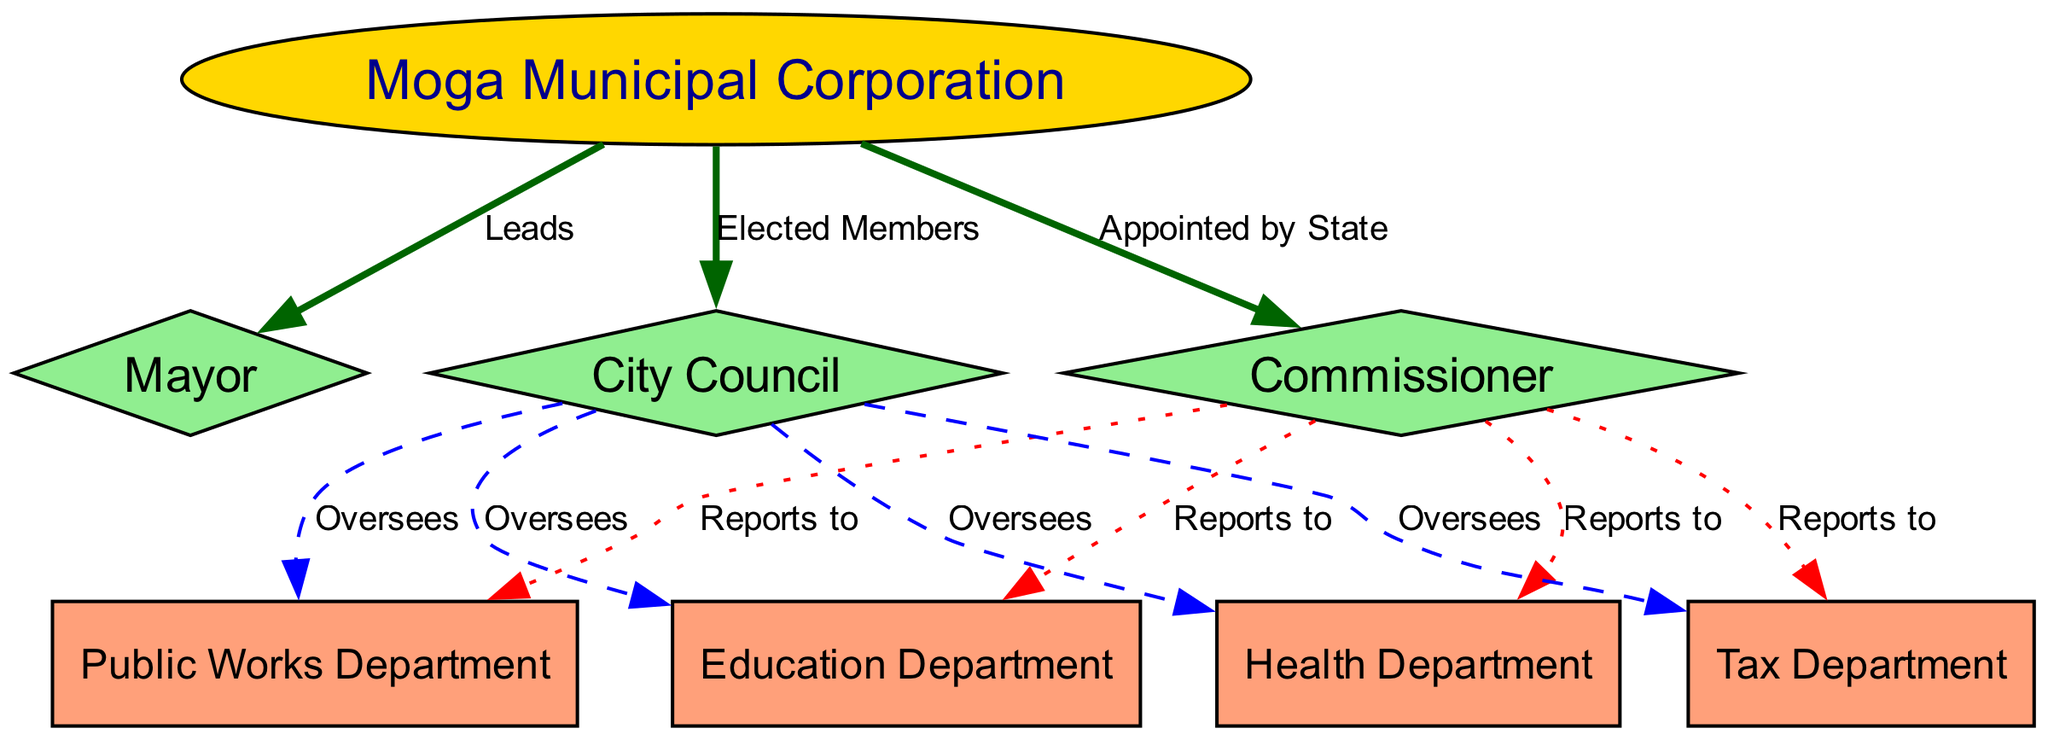What is the main entity in the diagram? The primary entity represented in the diagram is the Moga Municipal Corporation, denoted by the node labeled "Moga Municipal Corporation". It is represented as an ellipse, indicating its significance as the main organization overseeing local governance.
Answer: Moga Municipal Corporation How many departments are overseen by the City Council? The City Council oversees four departments, which include the Health Department, Education Department, Public Works Department, and Tax Department, as indicated by the four directed edges going from the Council to these departments.
Answer: 4 Who is appointed by the State? The Commissioner is the individual appointed by the State, as indicated by the edge labeled "Appointed by State" that connects the Moga Municipal Corporation to the Commissioner.
Answer: Commissioner What type of relationship does the Council have with the departments? The relationship between the Council and the departments is one of oversight, as indicated by the dashed edges labeled "Oversees" that connect the Council to each department.
Answer: Oversees Which department does the Commissioner report to? The Commissioner reports to the Health Department, Education Department, Public Works Department, and Tax Department, which is indicated by the dotted edges connecting the Commissioner to these departments.
Answer: All listed departments What is the shape of the node representing the Mayor? The node representing the Mayor is shaped like a diamond, indicating a role that is significant but distinct within the municipal structure, thereby differentiating it from regular departments and the main corporation.
Answer: Diamond How does the Mayor relate to the Moga Municipal Corporation? The Mayor leads the Moga Municipal Corporation, which is indicated by the directed edge labeled "Leads" connecting the Mayor to the Moga Municipal Corporation.
Answer: Leads What color are the departments in the diagram? The departments are represented with rectangular nodes filled with light salmon color, distinguishing them from the other roles like the Mayor and Commissioner which are shown in different shapes and colors.
Answer: Light salmon How many nodes are there in total within the diagram? There are eight nodes in total within the diagram, including the Moga Municipal Corporation, Mayor, Commissioner, Council, and the four departments listed.
Answer: 8 